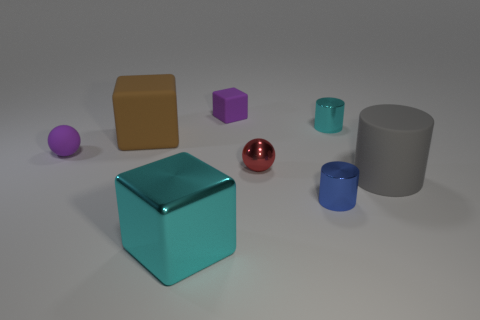Subtract all big blocks. How many blocks are left? 1 Add 1 big blue cubes. How many objects exist? 9 Subtract all blocks. How many objects are left? 5 Add 5 gray objects. How many gray objects exist? 6 Subtract 1 purple cubes. How many objects are left? 7 Subtract all big yellow metallic cylinders. Subtract all purple matte spheres. How many objects are left? 7 Add 8 cyan metal cylinders. How many cyan metal cylinders are left? 9 